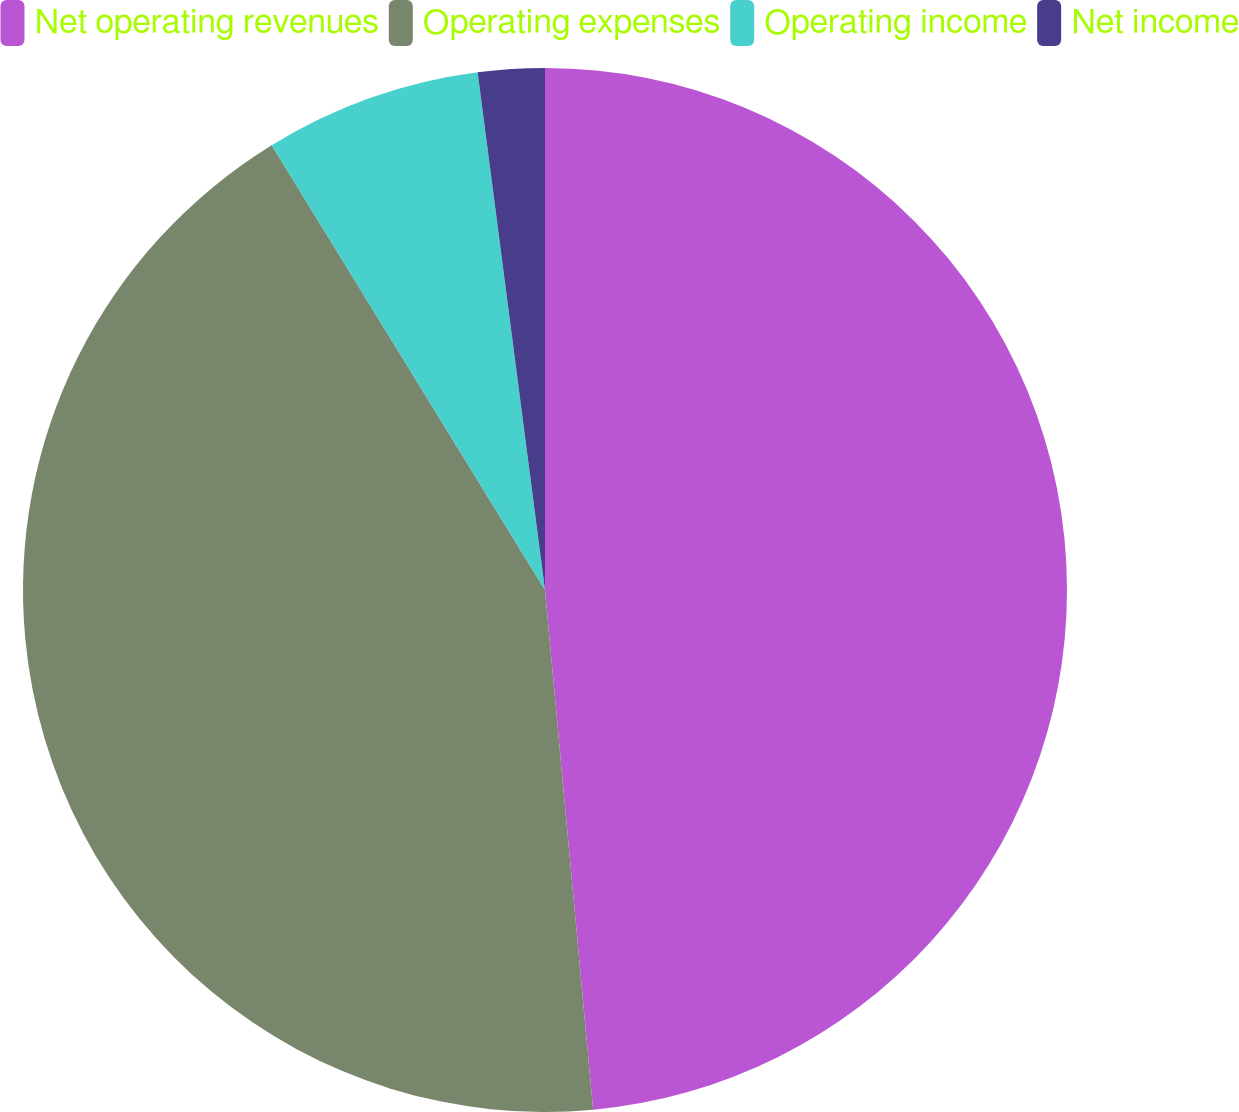Convert chart to OTSL. <chart><loc_0><loc_0><loc_500><loc_500><pie_chart><fcel>Net operating revenues<fcel>Operating expenses<fcel>Operating income<fcel>Net income<nl><fcel>48.53%<fcel>42.7%<fcel>6.71%<fcel>2.06%<nl></chart> 